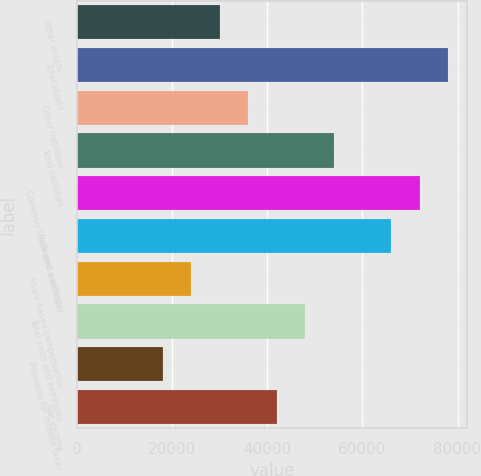Convert chart. <chart><loc_0><loc_0><loc_500><loc_500><bar_chart><fcel>Other assets<fcel>Total assets<fcel>Other liabilities<fcel>Total liabilities<fcel>Common stock and additional<fcel>Retained earnings<fcel>Share-based compensation<fcel>Total costs and expenses<fcel>Provision for income taxes<fcel>Net income<nl><fcel>30004<fcel>78008.8<fcel>36004.6<fcel>54006.4<fcel>72008.2<fcel>66007.6<fcel>24003.3<fcel>48005.8<fcel>18002.7<fcel>42005.2<nl></chart> 